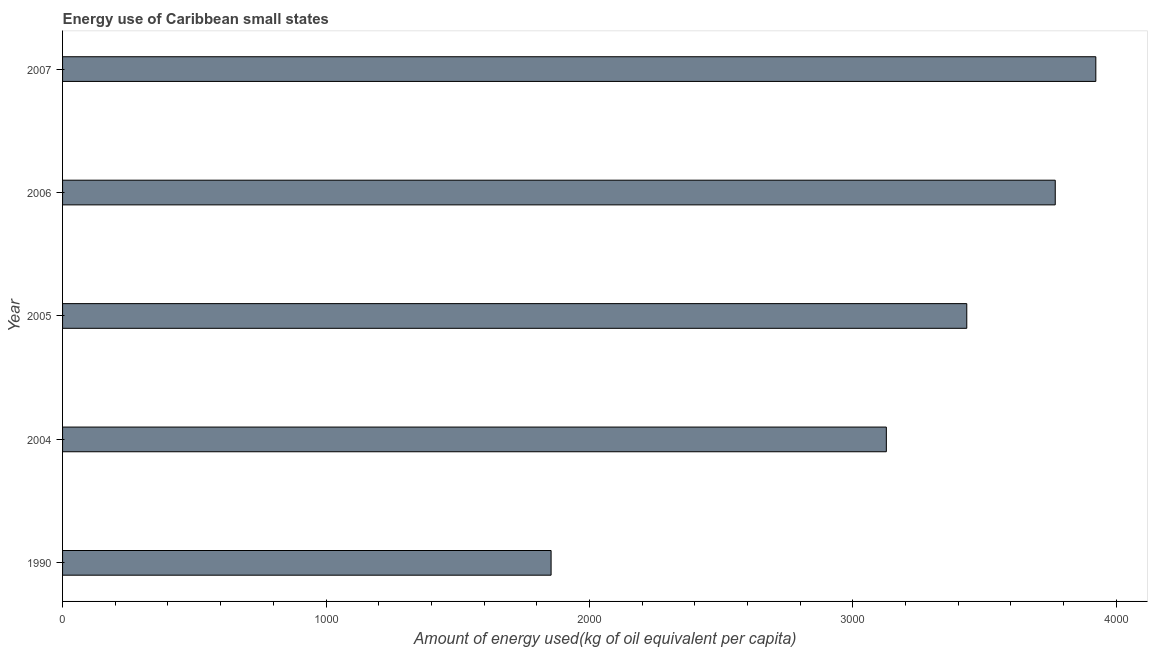What is the title of the graph?
Ensure brevity in your answer.  Energy use of Caribbean small states. What is the label or title of the X-axis?
Your answer should be compact. Amount of energy used(kg of oil equivalent per capita). What is the amount of energy used in 2005?
Provide a short and direct response. 3432.34. Across all years, what is the maximum amount of energy used?
Ensure brevity in your answer.  3922.17. Across all years, what is the minimum amount of energy used?
Keep it short and to the point. 1854.41. What is the sum of the amount of energy used?
Keep it short and to the point. 1.61e+04. What is the difference between the amount of energy used in 2004 and 2006?
Offer a very short reply. -641.17. What is the average amount of energy used per year?
Provide a succinct answer. 3220.81. What is the median amount of energy used?
Your answer should be compact. 3432.34. Do a majority of the years between 2006 and 2005 (inclusive) have amount of energy used greater than 3400 kg?
Give a very brief answer. No. What is the ratio of the amount of energy used in 1990 to that in 2005?
Provide a short and direct response. 0.54. What is the difference between the highest and the second highest amount of energy used?
Your response must be concise. 154.02. What is the difference between the highest and the lowest amount of energy used?
Offer a very short reply. 2067.76. In how many years, is the amount of energy used greater than the average amount of energy used taken over all years?
Your answer should be compact. 3. How many bars are there?
Offer a terse response. 5. What is the difference between two consecutive major ticks on the X-axis?
Your answer should be compact. 1000. Are the values on the major ticks of X-axis written in scientific E-notation?
Make the answer very short. No. What is the Amount of energy used(kg of oil equivalent per capita) in 1990?
Your answer should be very brief. 1854.41. What is the Amount of energy used(kg of oil equivalent per capita) of 2004?
Offer a very short reply. 3126.98. What is the Amount of energy used(kg of oil equivalent per capita) in 2005?
Your answer should be compact. 3432.34. What is the Amount of energy used(kg of oil equivalent per capita) in 2006?
Give a very brief answer. 3768.15. What is the Amount of energy used(kg of oil equivalent per capita) of 2007?
Your response must be concise. 3922.17. What is the difference between the Amount of energy used(kg of oil equivalent per capita) in 1990 and 2004?
Offer a very short reply. -1272.57. What is the difference between the Amount of energy used(kg of oil equivalent per capita) in 1990 and 2005?
Ensure brevity in your answer.  -1577.92. What is the difference between the Amount of energy used(kg of oil equivalent per capita) in 1990 and 2006?
Give a very brief answer. -1913.74. What is the difference between the Amount of energy used(kg of oil equivalent per capita) in 1990 and 2007?
Provide a short and direct response. -2067.76. What is the difference between the Amount of energy used(kg of oil equivalent per capita) in 2004 and 2005?
Your answer should be compact. -305.35. What is the difference between the Amount of energy used(kg of oil equivalent per capita) in 2004 and 2006?
Make the answer very short. -641.17. What is the difference between the Amount of energy used(kg of oil equivalent per capita) in 2004 and 2007?
Offer a very short reply. -795.19. What is the difference between the Amount of energy used(kg of oil equivalent per capita) in 2005 and 2006?
Ensure brevity in your answer.  -335.82. What is the difference between the Amount of energy used(kg of oil equivalent per capita) in 2005 and 2007?
Make the answer very short. -489.84. What is the difference between the Amount of energy used(kg of oil equivalent per capita) in 2006 and 2007?
Your response must be concise. -154.02. What is the ratio of the Amount of energy used(kg of oil equivalent per capita) in 1990 to that in 2004?
Provide a short and direct response. 0.59. What is the ratio of the Amount of energy used(kg of oil equivalent per capita) in 1990 to that in 2005?
Your response must be concise. 0.54. What is the ratio of the Amount of energy used(kg of oil equivalent per capita) in 1990 to that in 2006?
Ensure brevity in your answer.  0.49. What is the ratio of the Amount of energy used(kg of oil equivalent per capita) in 1990 to that in 2007?
Offer a very short reply. 0.47. What is the ratio of the Amount of energy used(kg of oil equivalent per capita) in 2004 to that in 2005?
Provide a short and direct response. 0.91. What is the ratio of the Amount of energy used(kg of oil equivalent per capita) in 2004 to that in 2006?
Make the answer very short. 0.83. What is the ratio of the Amount of energy used(kg of oil equivalent per capita) in 2004 to that in 2007?
Provide a short and direct response. 0.8. What is the ratio of the Amount of energy used(kg of oil equivalent per capita) in 2005 to that in 2006?
Give a very brief answer. 0.91. What is the ratio of the Amount of energy used(kg of oil equivalent per capita) in 2005 to that in 2007?
Provide a short and direct response. 0.88. What is the ratio of the Amount of energy used(kg of oil equivalent per capita) in 2006 to that in 2007?
Provide a succinct answer. 0.96. 